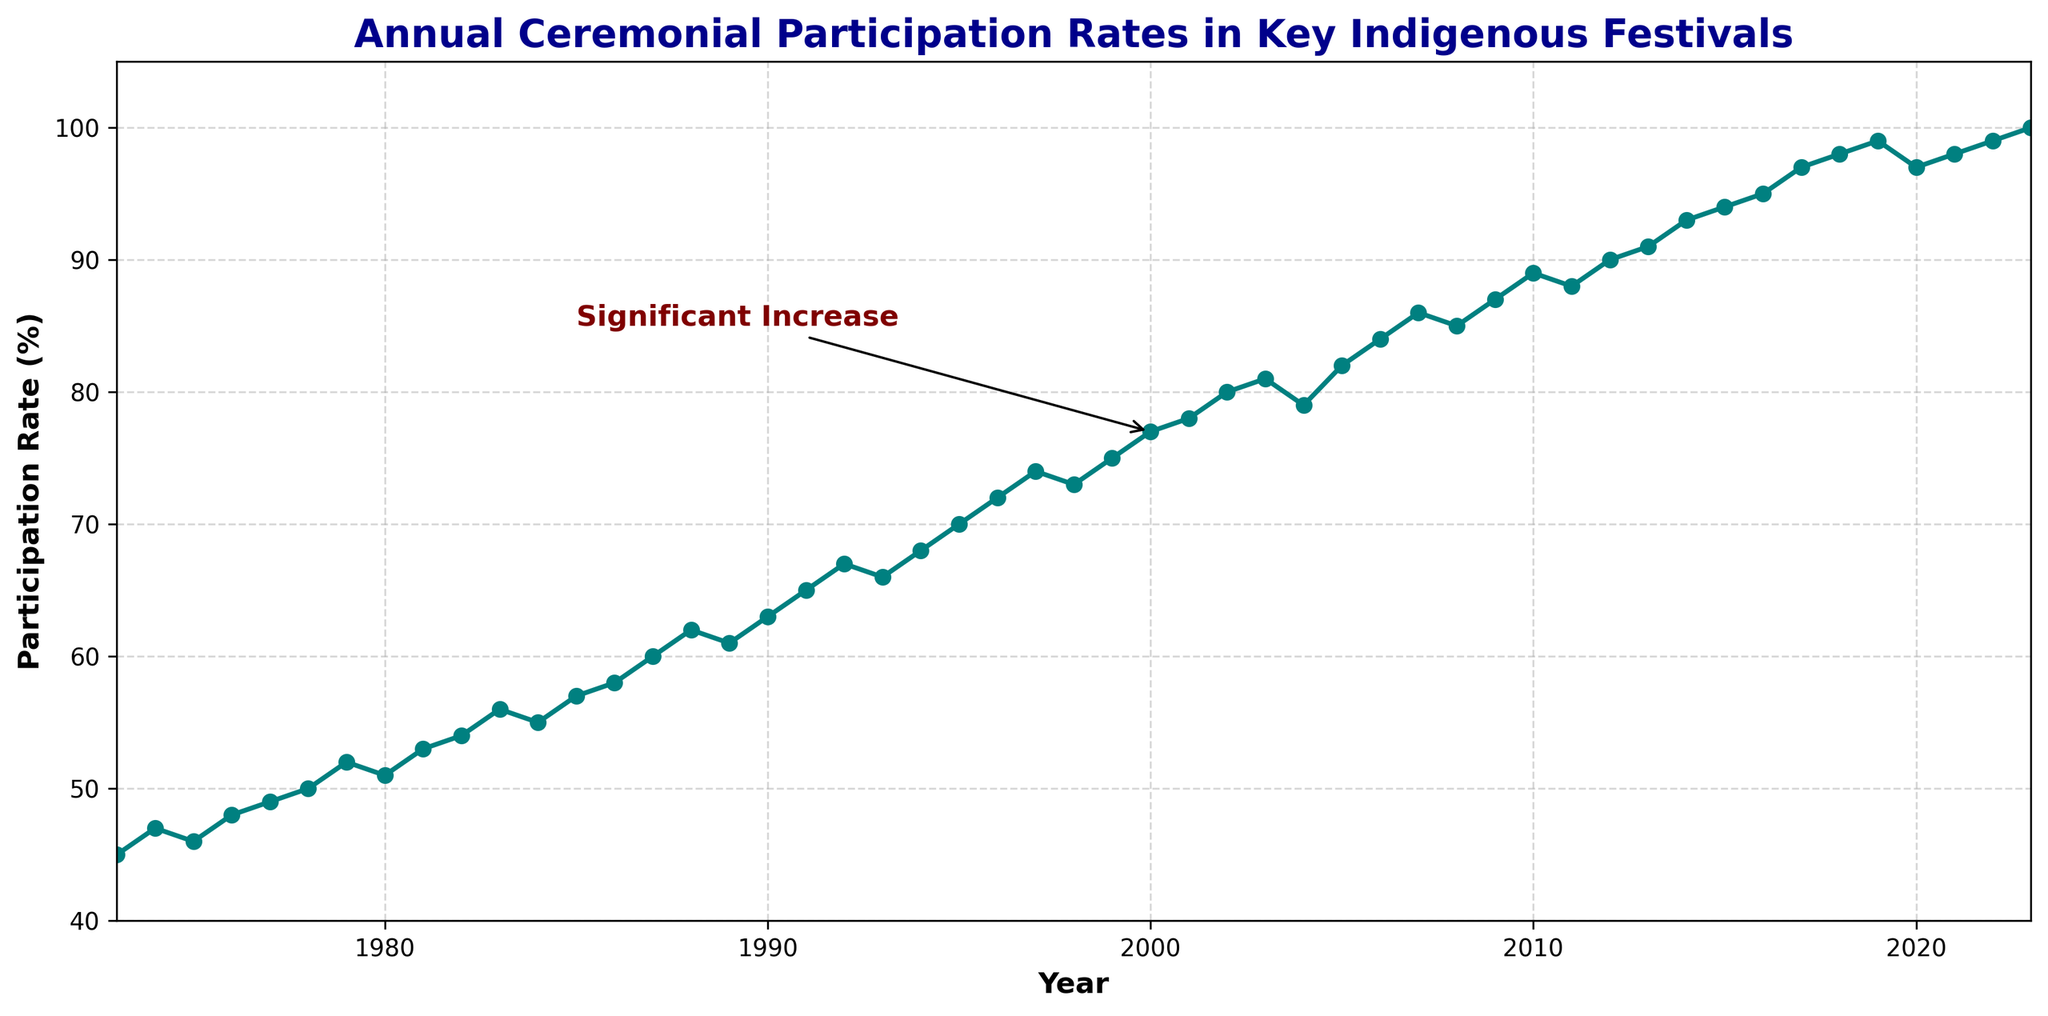What is the participation rate in 1973? Look at the participation rate value on the y-axis corresponding to the year 1973 on the x-axis. The participation rate is 45%.
Answer: 45% What was the participation rate in the year 2000 compared to 2020? In 2000, the participation rate is given as 77%, and in 2020, the rate is 97%. Comparing these, the rate increased by 20% from 2000 to 2020.
Answer: 20% increase Which year experienced a marked increase in participation rates as indicated by the text annotation? The text annotation 'Significant Increase' points to the year 2000 and the rate of 77%. This suggests a notable rise around this period.
Answer: 2000 What is the difference in participation rate between the year 2005 and 2010? In 2005, the participation rate is 82%, and in 2010, it is 89%. The difference is calculated as 89 - 82 = 7%.
Answer: 7% What was the participation trend from 1980 to 1990? From 1980 (51%) to 1990 (63%), the participation rate increased steadily. Summarizing the trend involves noting a consistent rise over this decade.
Answer: Increasing trend How many years had a participation rate of 90% or higher? From the figure, the rates 90% and higher are observable from 2012 onwards up to 2023. Counting the years, these are 2012 through 2023 inclusive, summing up to 12 years.
Answer: 12 years What is the median participation rate from 1973 to 2023? The median of a dataset is the middle value when the numbers are arranged in order. For this dataset of 50 years, the 25th and 26th years (1997 and 1998, with rates of 74% and 73%) average to give the median as (74+73)/2 = 73.5%.
Answer: 73.5% During which decade did the participation rate increase the most, based on an average annual change? Calculate the average annual change for each decade: 
- 1973-1982: (54-45)/10 = 0.9% per year
- 1983-1992: (67-56)/10 = 1.1% per year
- 1993-2002: (80-66)/10 = 1.4% per year
- 2003-2012: (90-81)/10 = 0.9% per year
- 2013-2022: (99-91)/10 = 0.8% per year
The highest increase is during the 1993-2002 decade, with a 1.4% increase per year.
Answer: 1993-2002 What is the visual indication used to highlight a noteworthy change in participation rates? The plot uses a text annotation 'Significant Increase' with an arrow pointing to the data point in the year 2000 at a participation rate of 77%. This helps draw attention to this notable change.
Answer: Text annotation with an arrow In which years did the participation rate reach exactly 95%? Observe the data points on the plot; the rate reaches exactly 95% in the year 2016.
Answer: 2016 